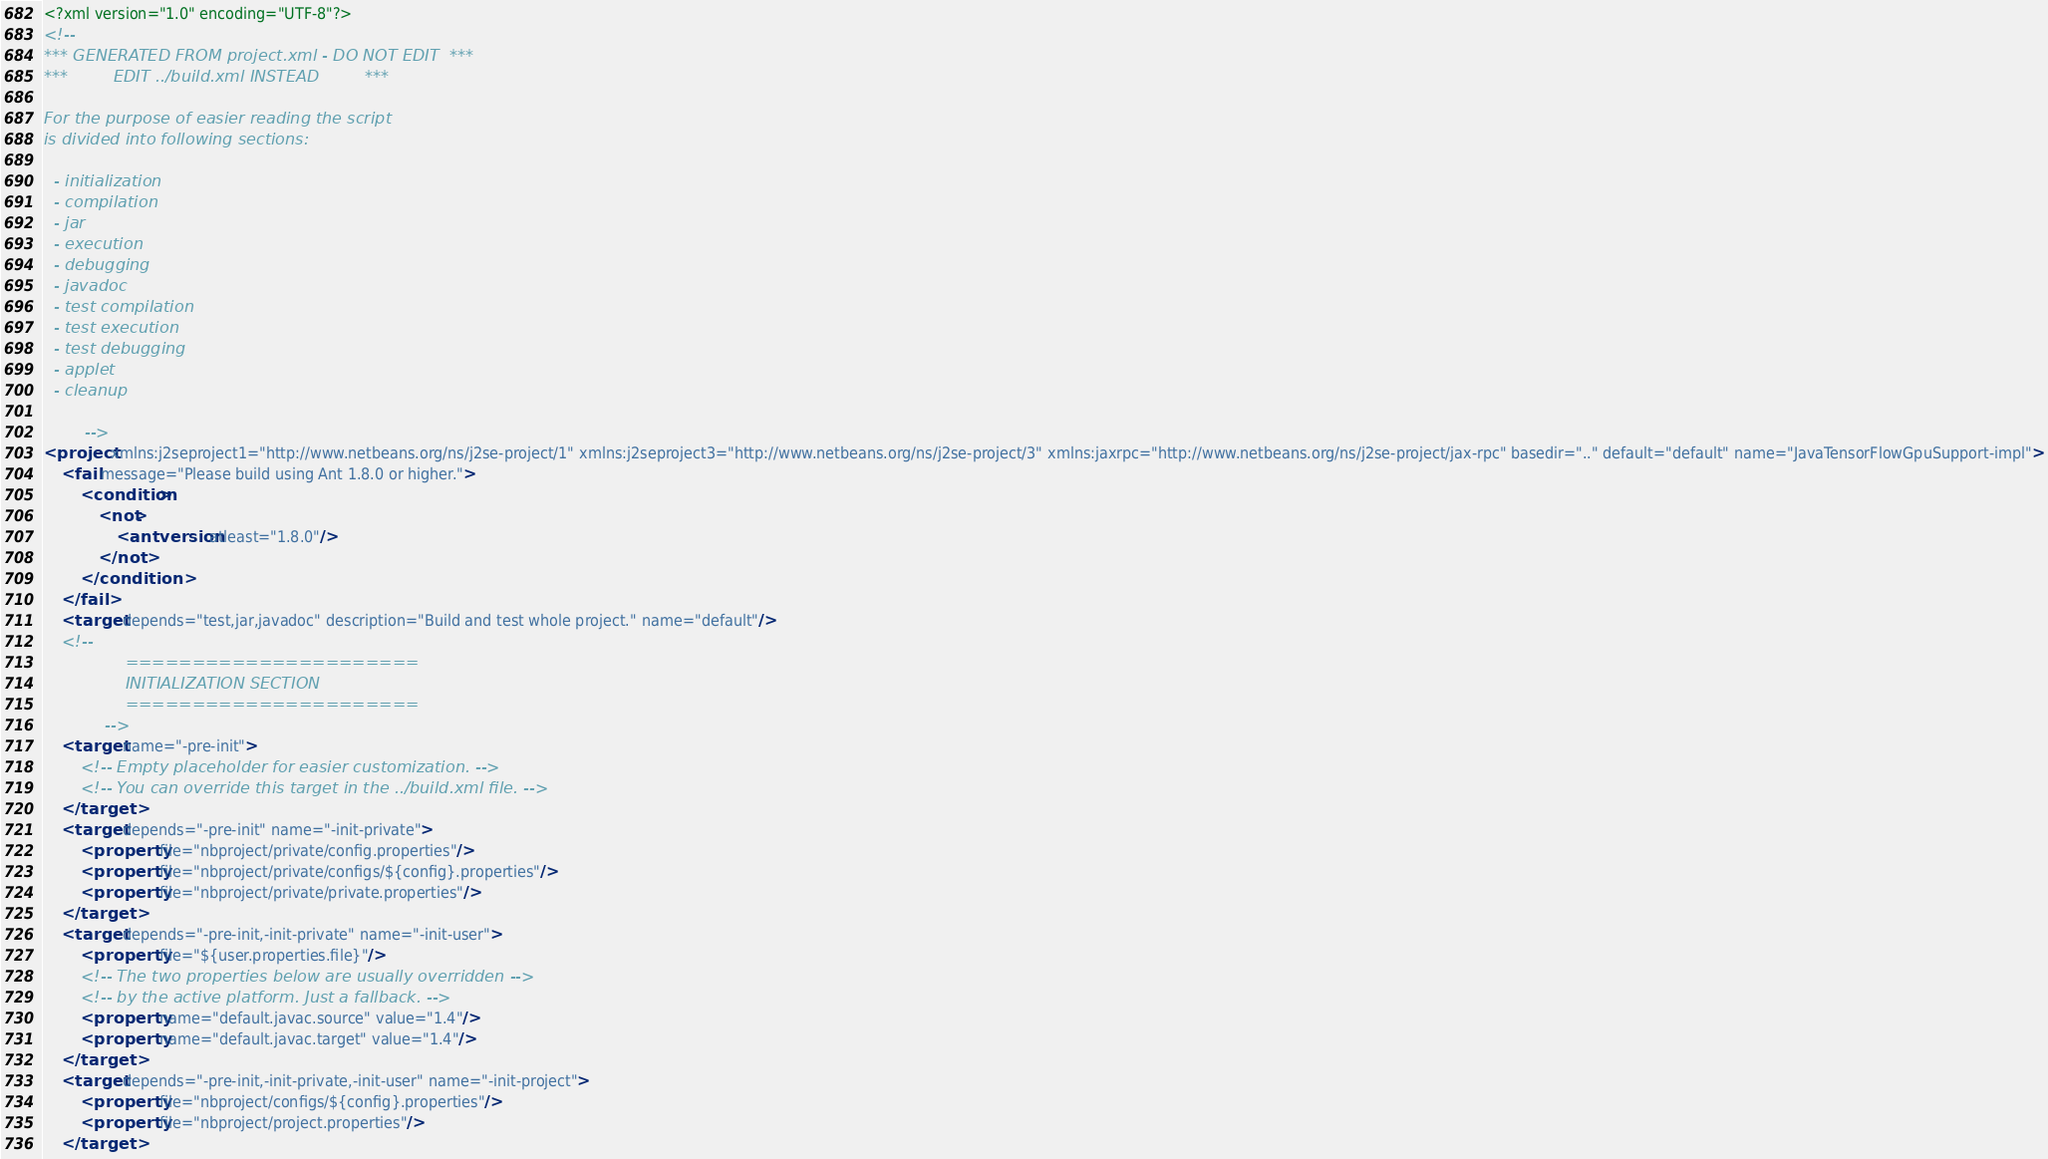Convert code to text. <code><loc_0><loc_0><loc_500><loc_500><_XML_><?xml version="1.0" encoding="UTF-8"?>
<!--
*** GENERATED FROM project.xml - DO NOT EDIT  ***
***         EDIT ../build.xml INSTEAD         ***

For the purpose of easier reading the script
is divided into following sections:

  - initialization
  - compilation
  - jar
  - execution
  - debugging
  - javadoc
  - test compilation
  - test execution
  - test debugging
  - applet
  - cleanup

        -->
<project xmlns:j2seproject1="http://www.netbeans.org/ns/j2se-project/1" xmlns:j2seproject3="http://www.netbeans.org/ns/j2se-project/3" xmlns:jaxrpc="http://www.netbeans.org/ns/j2se-project/jax-rpc" basedir=".." default="default" name="JavaTensorFlowGpuSupport-impl">
    <fail message="Please build using Ant 1.8.0 or higher.">
        <condition>
            <not>
                <antversion atleast="1.8.0"/>
            </not>
        </condition>
    </fail>
    <target depends="test,jar,javadoc" description="Build and test whole project." name="default"/>
    <!-- 
                ======================
                INITIALIZATION SECTION 
                ======================
            -->
    <target name="-pre-init">
        <!-- Empty placeholder for easier customization. -->
        <!-- You can override this target in the ../build.xml file. -->
    </target>
    <target depends="-pre-init" name="-init-private">
        <property file="nbproject/private/config.properties"/>
        <property file="nbproject/private/configs/${config}.properties"/>
        <property file="nbproject/private/private.properties"/>
    </target>
    <target depends="-pre-init,-init-private" name="-init-user">
        <property file="${user.properties.file}"/>
        <!-- The two properties below are usually overridden -->
        <!-- by the active platform. Just a fallback. -->
        <property name="default.javac.source" value="1.4"/>
        <property name="default.javac.target" value="1.4"/>
    </target>
    <target depends="-pre-init,-init-private,-init-user" name="-init-project">
        <property file="nbproject/configs/${config}.properties"/>
        <property file="nbproject/project.properties"/>
    </target></code> 